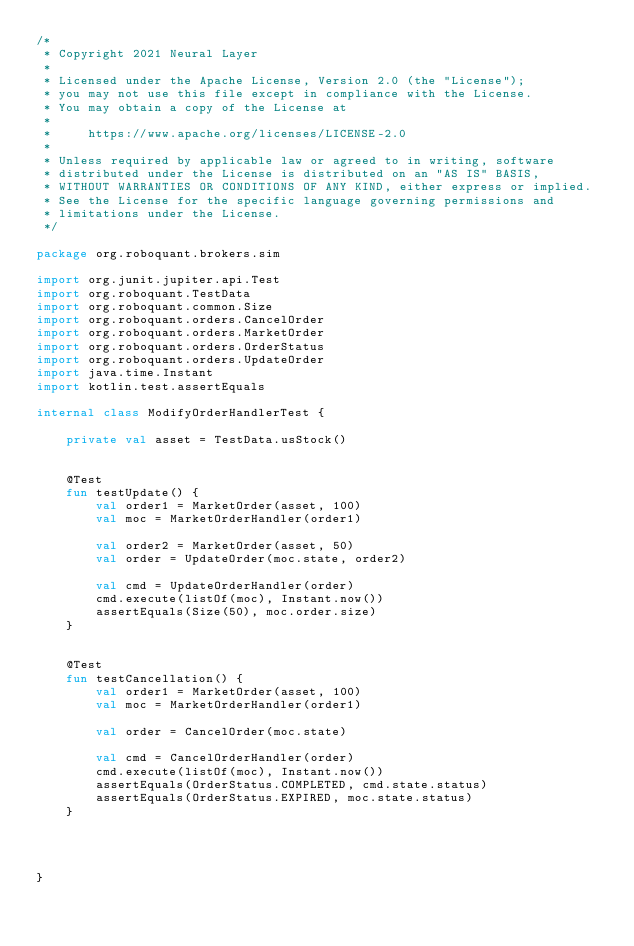<code> <loc_0><loc_0><loc_500><loc_500><_Kotlin_>/*
 * Copyright 2021 Neural Layer
 *
 * Licensed under the Apache License, Version 2.0 (the "License");
 * you may not use this file except in compliance with the License.
 * You may obtain a copy of the License at
 *
 *     https://www.apache.org/licenses/LICENSE-2.0
 *
 * Unless required by applicable law or agreed to in writing, software
 * distributed under the License is distributed on an "AS IS" BASIS,
 * WITHOUT WARRANTIES OR CONDITIONS OF ANY KIND, either express or implied.
 * See the License for the specific language governing permissions and
 * limitations under the License.
 */

package org.roboquant.brokers.sim

import org.junit.jupiter.api.Test
import org.roboquant.TestData
import org.roboquant.common.Size
import org.roboquant.orders.CancelOrder
import org.roboquant.orders.MarketOrder
import org.roboquant.orders.OrderStatus
import org.roboquant.orders.UpdateOrder
import java.time.Instant
import kotlin.test.assertEquals

internal class ModifyOrderHandlerTest {

    private val asset = TestData.usStock()


    @Test
    fun testUpdate() {
        val order1 = MarketOrder(asset, 100)
        val moc = MarketOrderHandler(order1)

        val order2 = MarketOrder(asset, 50)
        val order = UpdateOrder(moc.state, order2)

        val cmd = UpdateOrderHandler(order)
        cmd.execute(listOf(moc), Instant.now())
        assertEquals(Size(50), moc.order.size)
    }


    @Test
    fun testCancellation() {
        val order1 = MarketOrder(asset, 100)
        val moc = MarketOrderHandler(order1)

        val order = CancelOrder(moc.state)

        val cmd = CancelOrderHandler(order)
        cmd.execute(listOf(moc), Instant.now())
        assertEquals(OrderStatus.COMPLETED, cmd.state.status)
        assertEquals(OrderStatus.EXPIRED, moc.state.status)
    }




}</code> 